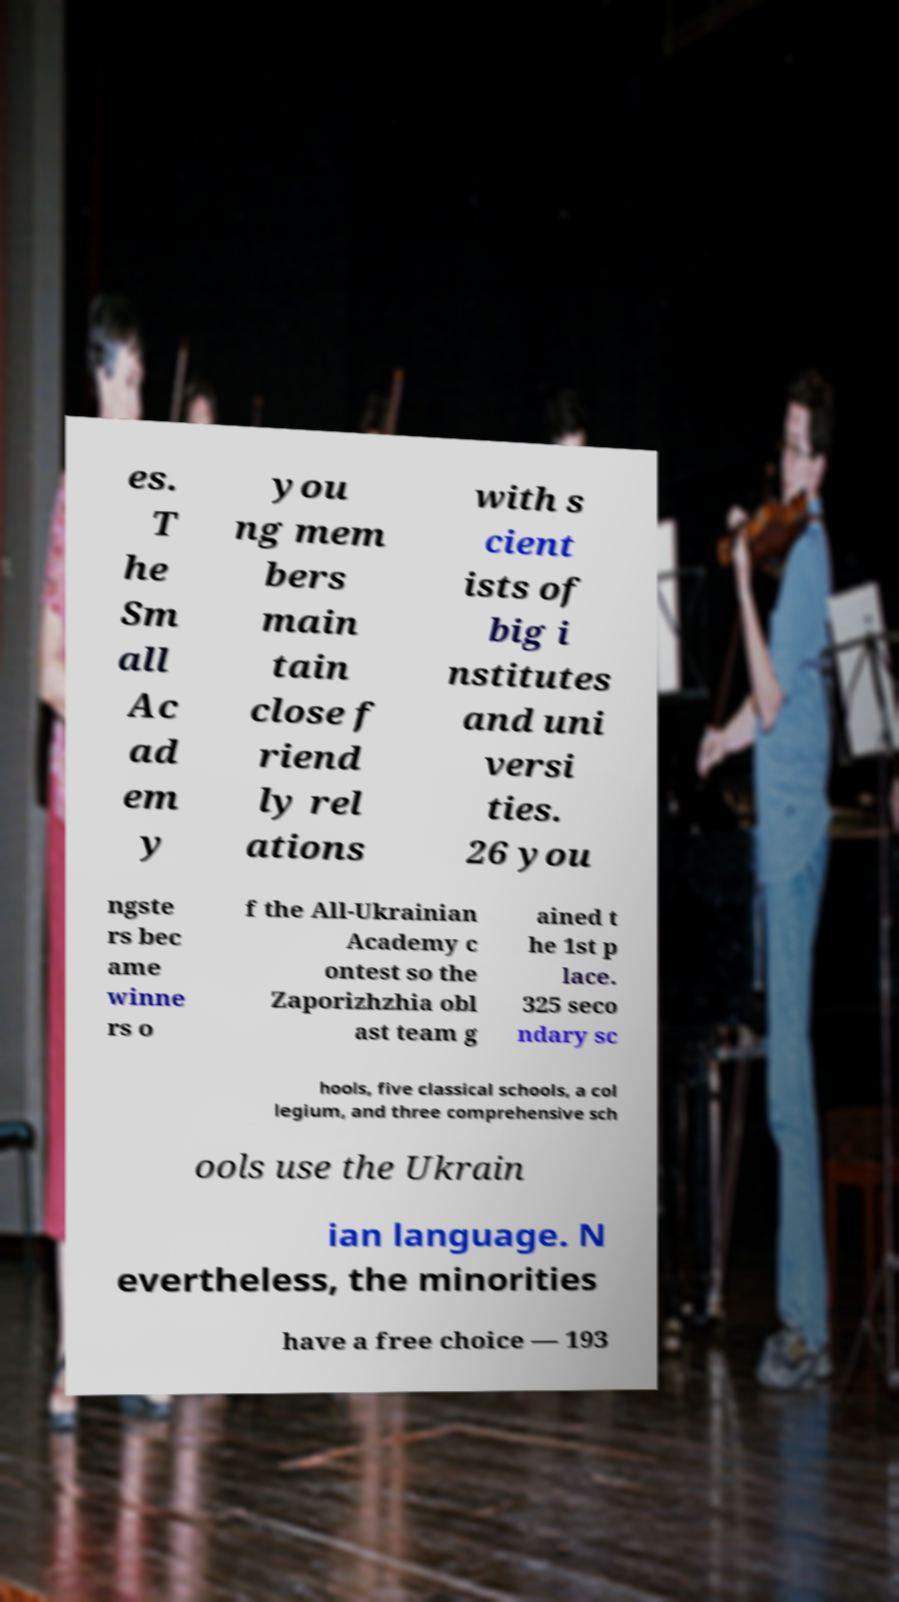For documentation purposes, I need the text within this image transcribed. Could you provide that? es. T he Sm all Ac ad em y you ng mem bers main tain close f riend ly rel ations with s cient ists of big i nstitutes and uni versi ties. 26 you ngste rs bec ame winne rs o f the All-Ukrainian Academy c ontest so the Zaporizhzhia obl ast team g ained t he 1st p lace. 325 seco ndary sc hools, five classical schools, a col legium, and three comprehensive sch ools use the Ukrain ian language. N evertheless, the minorities have a free choice — 193 